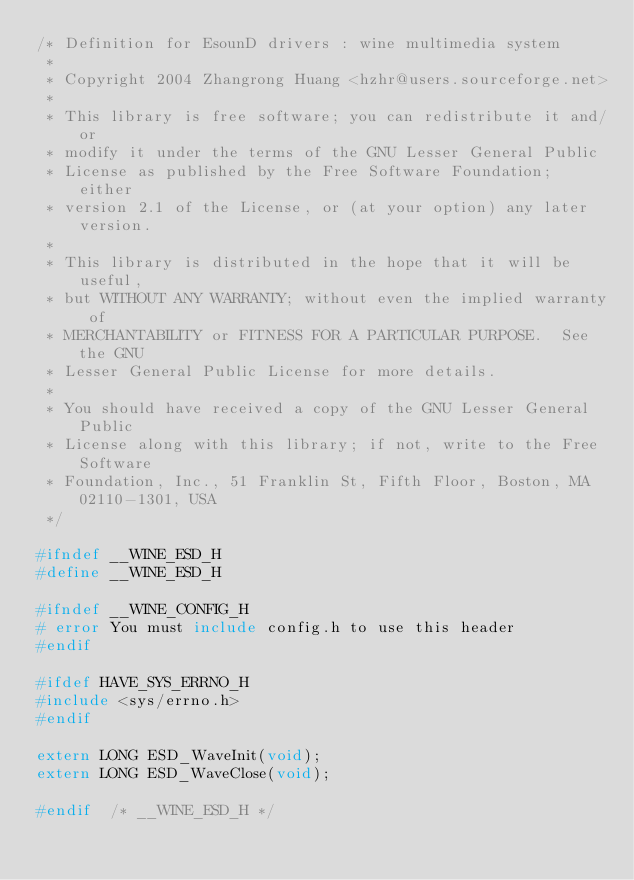<code> <loc_0><loc_0><loc_500><loc_500><_C_>/* Definition for EsounD drivers : wine multimedia system
 *
 * Copyright 2004 Zhangrong Huang <hzhr@users.sourceforge.net>
 *
 * This library is free software; you can redistribute it and/or
 * modify it under the terms of the GNU Lesser General Public
 * License as published by the Free Software Foundation; either
 * version 2.1 of the License, or (at your option) any later version.
 *
 * This library is distributed in the hope that it will be useful,
 * but WITHOUT ANY WARRANTY; without even the implied warranty of
 * MERCHANTABILITY or FITNESS FOR A PARTICULAR PURPOSE.  See the GNU
 * Lesser General Public License for more details.
 *
 * You should have received a copy of the GNU Lesser General Public
 * License along with this library; if not, write to the Free Software
 * Foundation, Inc., 51 Franklin St, Fifth Floor, Boston, MA 02110-1301, USA
 */

#ifndef __WINE_ESD_H
#define __WINE_ESD_H

#ifndef __WINE_CONFIG_H
# error You must include config.h to use this header
#endif

#ifdef HAVE_SYS_ERRNO_H
#include <sys/errno.h>
#endif

extern LONG ESD_WaveInit(void);
extern LONG ESD_WaveClose(void);

#endif  /* __WINE_ESD_H */
</code> 